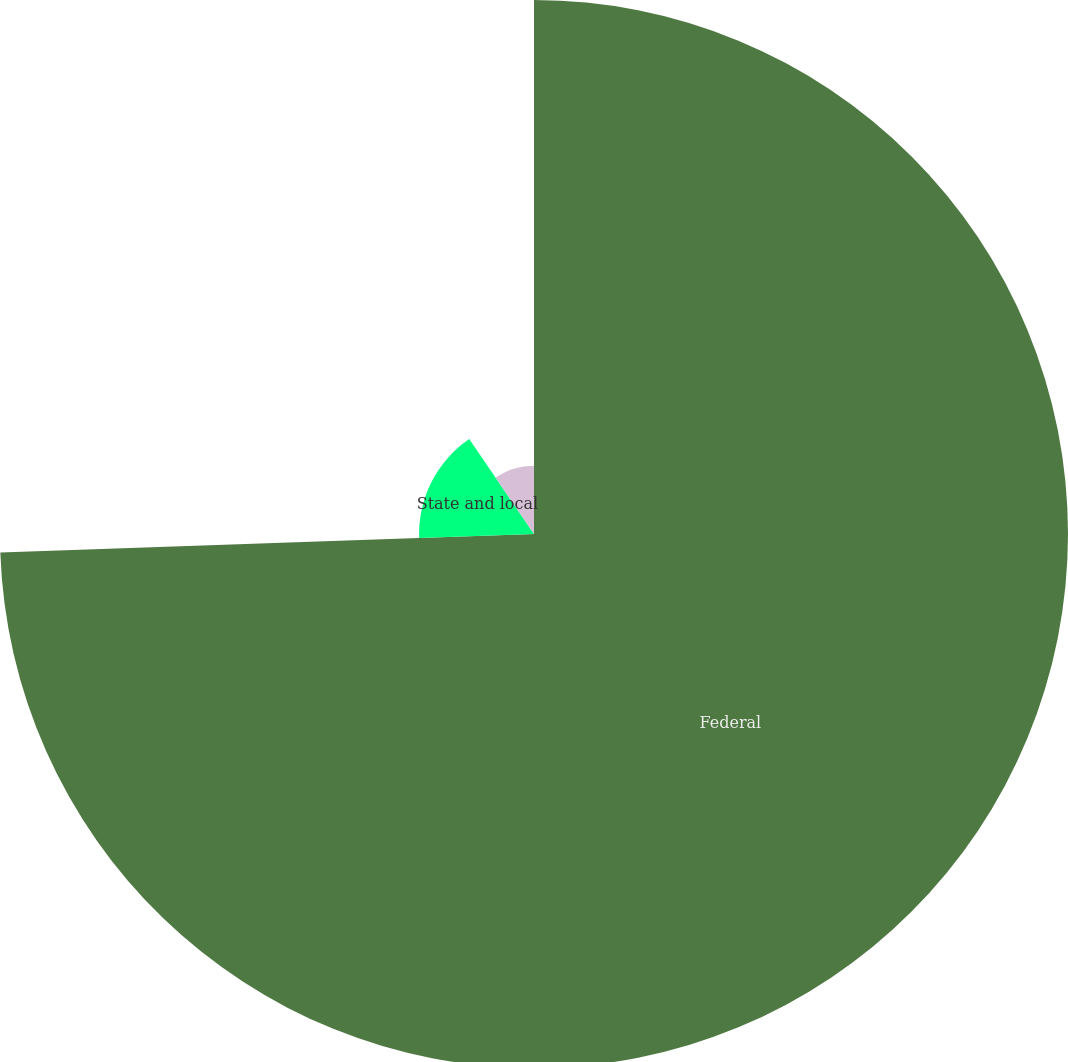Convert chart. <chart><loc_0><loc_0><loc_500><loc_500><pie_chart><fcel>Federal<fcel>State and local<fcel>Foreign<nl><fcel>74.45%<fcel>16.02%<fcel>9.53%<nl></chart> 